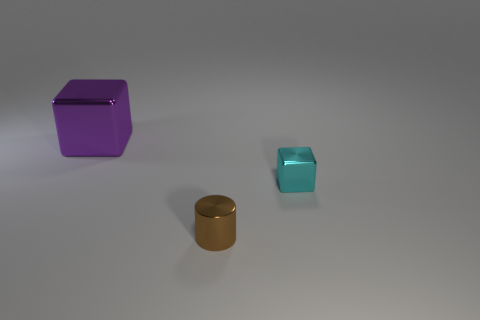There is a metallic thing on the right side of the tiny cylinder; does it have the same shape as the large purple object behind the brown metallic object?
Your answer should be very brief. Yes. The metallic object in front of the tiny cube has what shape?
Your response must be concise. Cylinder. Are there an equal number of brown shiny cylinders right of the tiny shiny block and purple metallic blocks behind the purple thing?
Ensure brevity in your answer.  Yes. What number of things are either large cyan rubber cubes or shiny things that are in front of the large purple thing?
Give a very brief answer. 2. There is a object that is both to the left of the small cyan thing and on the right side of the purple shiny thing; what is its shape?
Keep it short and to the point. Cylinder. What material is the cube in front of the metallic block to the left of the small brown metal cylinder?
Your response must be concise. Metal. Is the material of the block that is to the right of the small cylinder the same as the tiny brown thing?
Your response must be concise. Yes. There is a block that is in front of the large metal block; how big is it?
Your response must be concise. Small. There is a shiny block that is to the right of the big shiny thing; is there a purple metallic block that is on the right side of it?
Offer a very short reply. No. Do the shiny object behind the tiny block and the metallic thing right of the brown object have the same color?
Keep it short and to the point. No. 